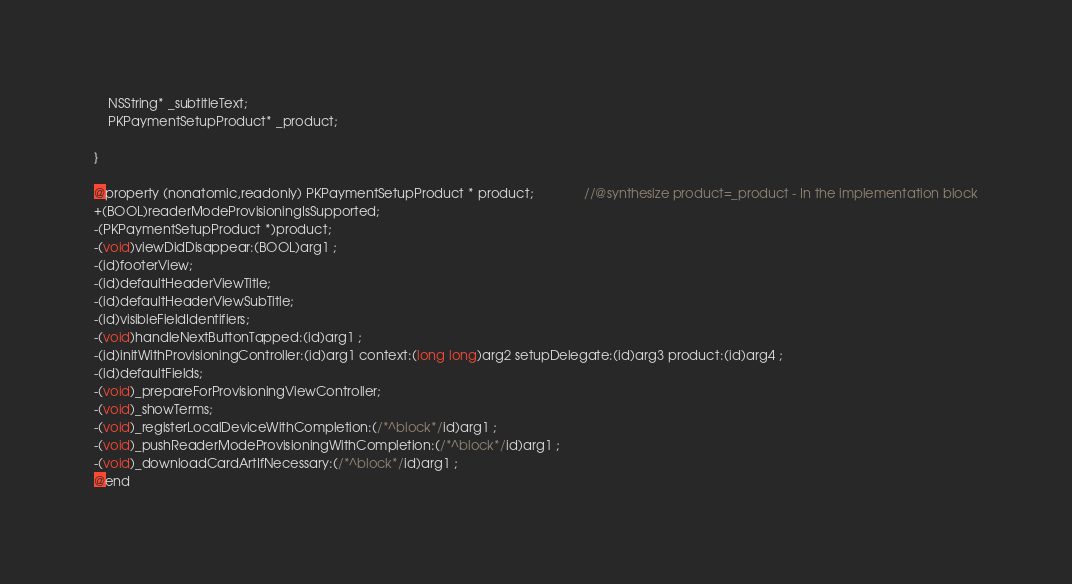Convert code to text. <code><loc_0><loc_0><loc_500><loc_500><_C_>	NSString* _subtitleText;
	PKPaymentSetupProduct* _product;

}

@property (nonatomic,readonly) PKPaymentSetupProduct * product;              //@synthesize product=_product - In the implementation block
+(BOOL)readerModeProvisioningIsSupported;
-(PKPaymentSetupProduct *)product;
-(void)viewDidDisappear:(BOOL)arg1 ;
-(id)footerView;
-(id)defaultHeaderViewTitle;
-(id)defaultHeaderViewSubTitle;
-(id)visibleFieldIdentifiers;
-(void)handleNextButtonTapped:(id)arg1 ;
-(id)initWithProvisioningController:(id)arg1 context:(long long)arg2 setupDelegate:(id)arg3 product:(id)arg4 ;
-(id)defaultFields;
-(void)_prepareForProvisioningViewController;
-(void)_showTerms;
-(void)_registerLocalDeviceWithCompletion:(/*^block*/id)arg1 ;
-(void)_pushReaderModeProvisioningWithCompletion:(/*^block*/id)arg1 ;
-(void)_downloadCardArtIfNecessary:(/*^block*/id)arg1 ;
@end

</code> 